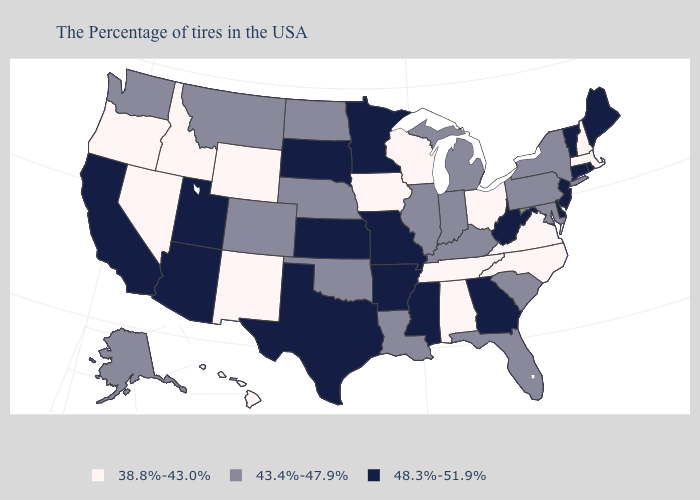Among the states that border West Virginia , which have the lowest value?
Short answer required. Virginia, Ohio. What is the lowest value in the West?
Short answer required. 38.8%-43.0%. Among the states that border Missouri , does Kansas have the highest value?
Quick response, please. Yes. Does Delaware have the same value as Minnesota?
Concise answer only. Yes. What is the highest value in states that border Virginia?
Concise answer only. 48.3%-51.9%. What is the value of Colorado?
Write a very short answer. 43.4%-47.9%. Does the first symbol in the legend represent the smallest category?
Quick response, please. Yes. Name the states that have a value in the range 43.4%-47.9%?
Give a very brief answer. New York, Maryland, Pennsylvania, South Carolina, Florida, Michigan, Kentucky, Indiana, Illinois, Louisiana, Nebraska, Oklahoma, North Dakota, Colorado, Montana, Washington, Alaska. Name the states that have a value in the range 38.8%-43.0%?
Quick response, please. Massachusetts, New Hampshire, Virginia, North Carolina, Ohio, Alabama, Tennessee, Wisconsin, Iowa, Wyoming, New Mexico, Idaho, Nevada, Oregon, Hawaii. Which states have the highest value in the USA?
Quick response, please. Maine, Rhode Island, Vermont, Connecticut, New Jersey, Delaware, West Virginia, Georgia, Mississippi, Missouri, Arkansas, Minnesota, Kansas, Texas, South Dakota, Utah, Arizona, California. Among the states that border Alabama , which have the highest value?
Short answer required. Georgia, Mississippi. What is the value of Missouri?
Keep it brief. 48.3%-51.9%. What is the value of Wyoming?
Concise answer only. 38.8%-43.0%. What is the value of Georgia?
Keep it brief. 48.3%-51.9%. Name the states that have a value in the range 38.8%-43.0%?
Concise answer only. Massachusetts, New Hampshire, Virginia, North Carolina, Ohio, Alabama, Tennessee, Wisconsin, Iowa, Wyoming, New Mexico, Idaho, Nevada, Oregon, Hawaii. 